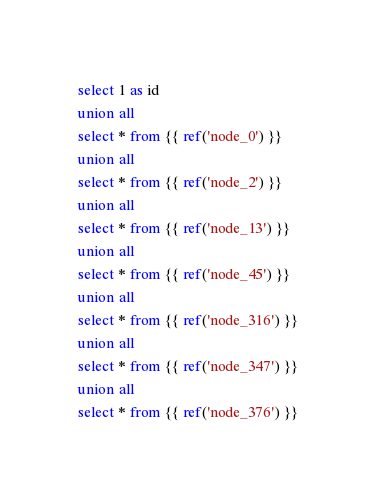Convert code to text. <code><loc_0><loc_0><loc_500><loc_500><_SQL_>select 1 as id
union all
select * from {{ ref('node_0') }}
union all
select * from {{ ref('node_2') }}
union all
select * from {{ ref('node_13') }}
union all
select * from {{ ref('node_45') }}
union all
select * from {{ ref('node_316') }}
union all
select * from {{ ref('node_347') }}
union all
select * from {{ ref('node_376') }}
</code> 